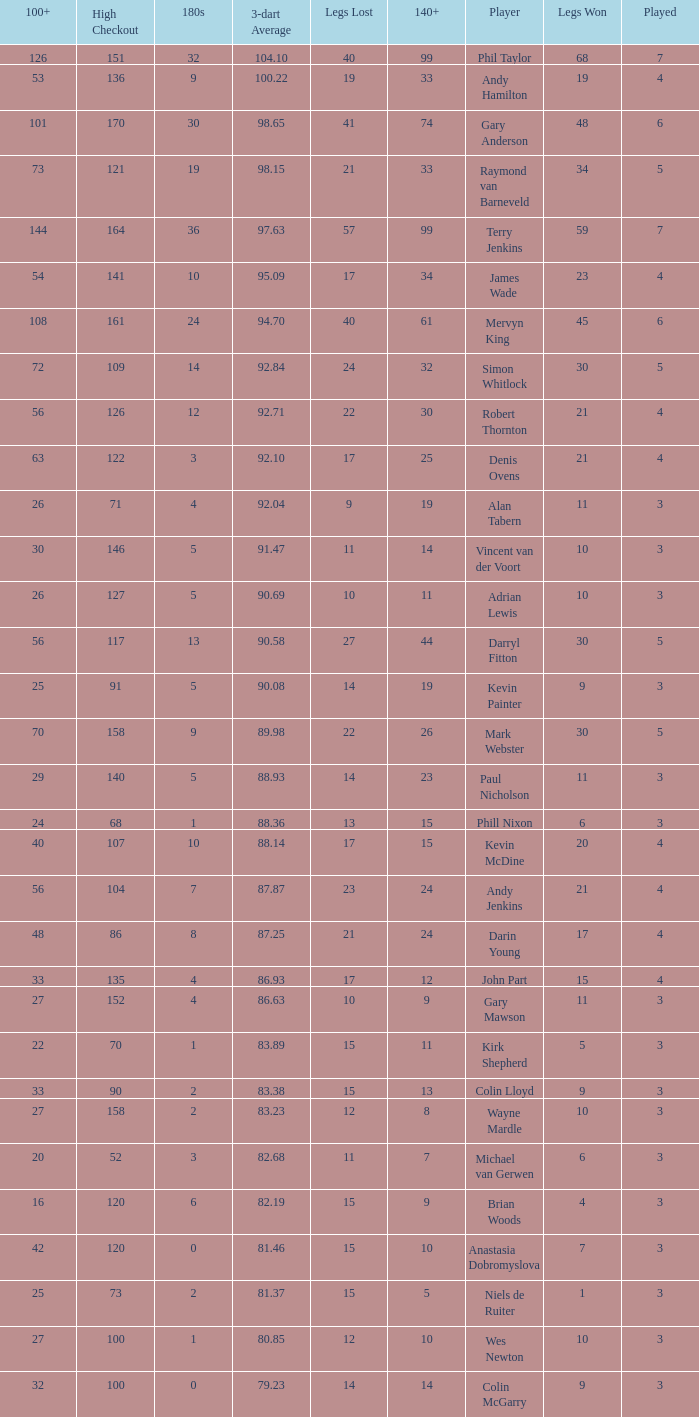What is the number of high checkout when legs Lost is 17, 140+ is 15, and played is larger than 4? None. 